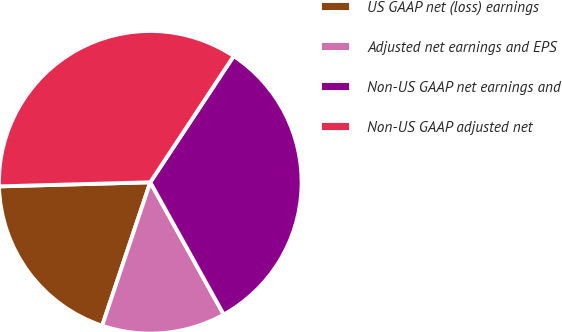Convert chart. <chart><loc_0><loc_0><loc_500><loc_500><pie_chart><fcel>US GAAP net (loss) earnings<fcel>Adjusted net earnings and EPS<fcel>Non-US GAAP net earnings and<fcel>Non-US GAAP adjusted net<nl><fcel>19.42%<fcel>13.22%<fcel>32.64%<fcel>34.73%<nl></chart> 